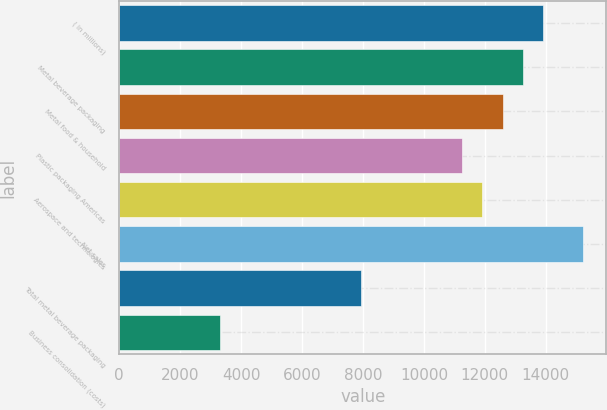Convert chart to OTSL. <chart><loc_0><loc_0><loc_500><loc_500><bar_chart><fcel>( in millions)<fcel>Metal beverage packaging<fcel>Metal food & household<fcel>Plastic packaging Americas<fcel>Aerospace and technologies<fcel>Net sales<fcel>Total metal beverage packaging<fcel>Business consolidation (costs)<nl><fcel>13904.7<fcel>13242.6<fcel>12580.5<fcel>11256.3<fcel>11918.4<fcel>15228.9<fcel>7945.72<fcel>3310.95<nl></chart> 